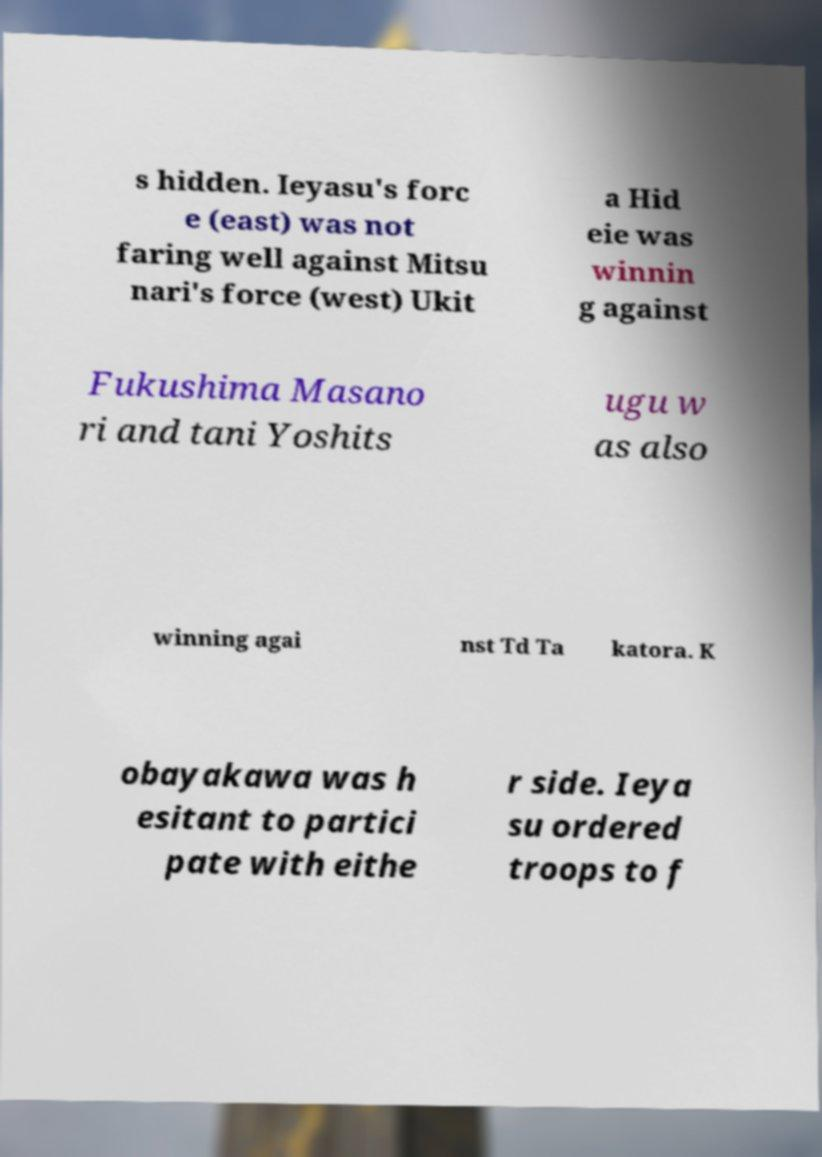For documentation purposes, I need the text within this image transcribed. Could you provide that? s hidden. Ieyasu's forc e (east) was not faring well against Mitsu nari's force (west) Ukit a Hid eie was winnin g against Fukushima Masano ri and tani Yoshits ugu w as also winning agai nst Td Ta katora. K obayakawa was h esitant to partici pate with eithe r side. Ieya su ordered troops to f 